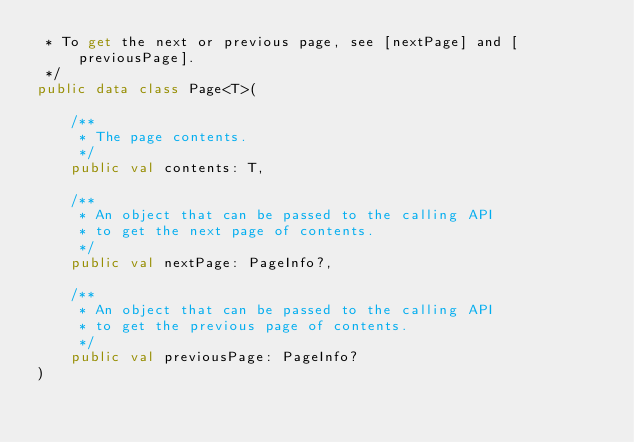<code> <loc_0><loc_0><loc_500><loc_500><_Kotlin_> * To get the next or previous page, see [nextPage] and [previousPage].
 */
public data class Page<T>(

    /**
     * The page contents.
     */
    public val contents: T,

    /**
     * An object that can be passed to the calling API
     * to get the next page of contents.
     */
    public val nextPage: PageInfo?,

    /**
     * An object that can be passed to the calling API
     * to get the previous page of contents.
     */
    public val previousPage: PageInfo?
)
</code> 